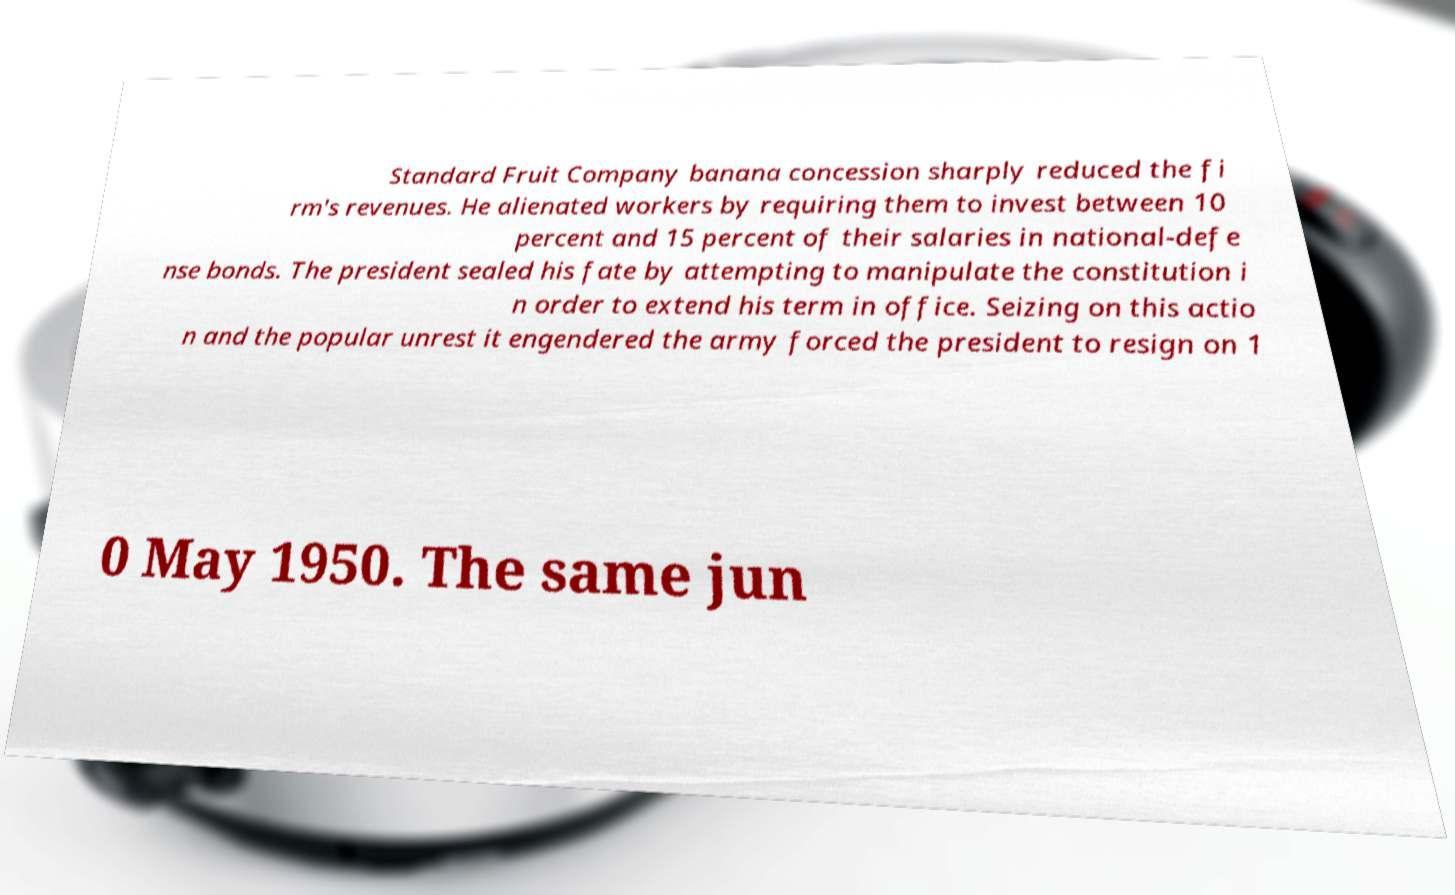For documentation purposes, I need the text within this image transcribed. Could you provide that? Standard Fruit Company banana concession sharply reduced the fi rm's revenues. He alienated workers by requiring them to invest between 10 percent and 15 percent of their salaries in national-defe nse bonds. The president sealed his fate by attempting to manipulate the constitution i n order to extend his term in office. Seizing on this actio n and the popular unrest it engendered the army forced the president to resign on 1 0 May 1950. The same jun 